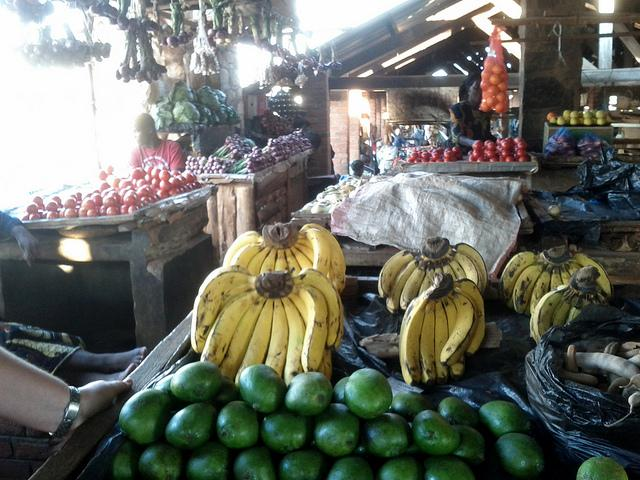What color is the fruit located under the bananas? Please explain your reasoning. green. The bananas are over the mangoes. the mangoes in this image are unripe. 